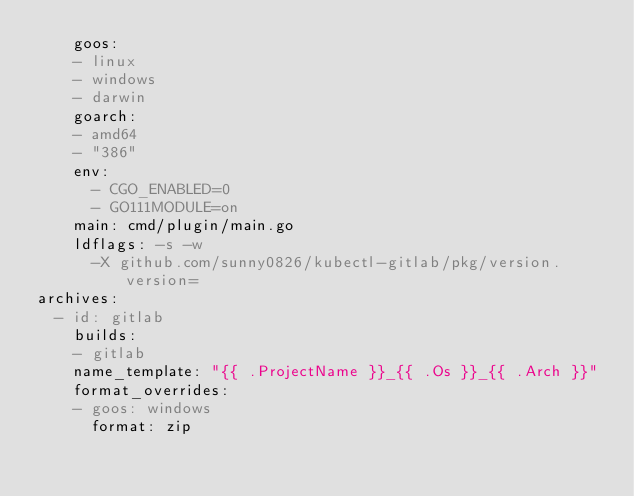Convert code to text. <code><loc_0><loc_0><loc_500><loc_500><_YAML_>    goos:
    - linux
    - windows
    - darwin
    goarch:
    - amd64
    - "386"
    env:
      - CGO_ENABLED=0
      - GO111MODULE=on
    main: cmd/plugin/main.go
    ldflags: -s -w
      -X github.com/sunny0826/kubectl-gitlab/pkg/version.version=
archives:
  - id: gitlab
    builds:
    - gitlab
    name_template: "{{ .ProjectName }}_{{ .Os }}_{{ .Arch }}"
    format_overrides:
    - goos: windows
      format: zip
</code> 